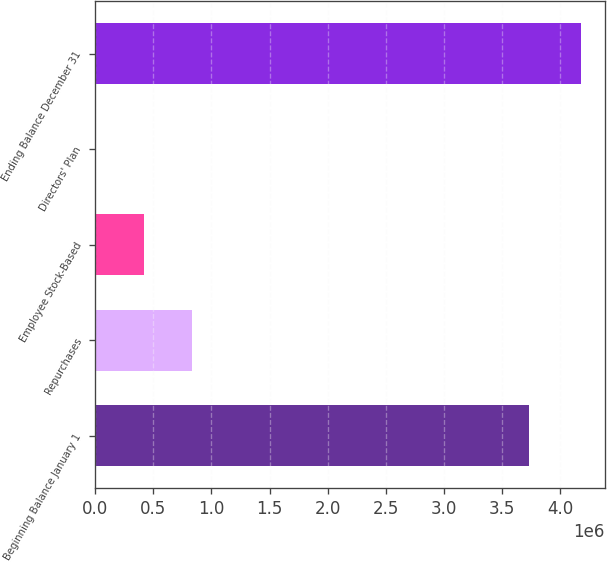<chart> <loc_0><loc_0><loc_500><loc_500><bar_chart><fcel>Beginning Balance January 1<fcel>Repurchases<fcel>Employee Stock-Based<fcel>Directors' Plan<fcel>Ending Balance December 31<nl><fcel>3.73486e+06<fcel>835336<fcel>417851<fcel>366<fcel>4.17521e+06<nl></chart> 